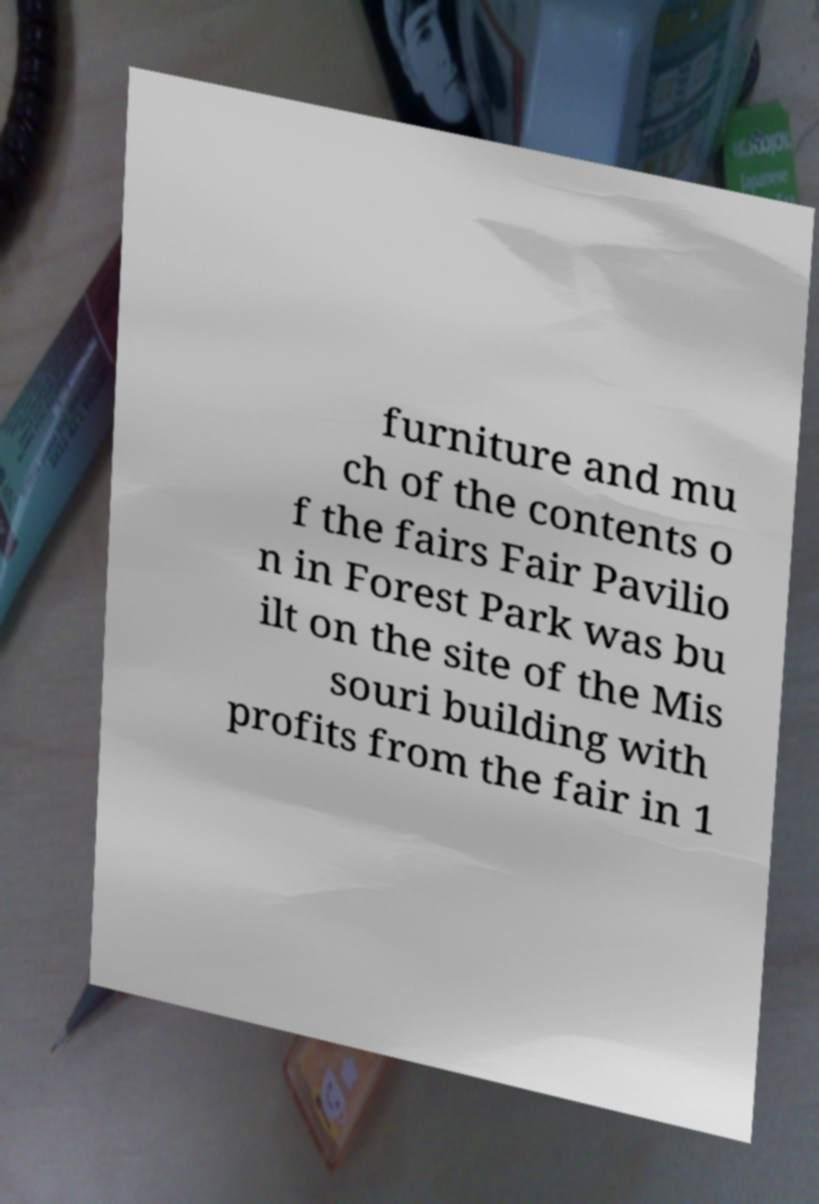I need the written content from this picture converted into text. Can you do that? furniture and mu ch of the contents o f the fairs Fair Pavilio n in Forest Park was bu ilt on the site of the Mis souri building with profits from the fair in 1 